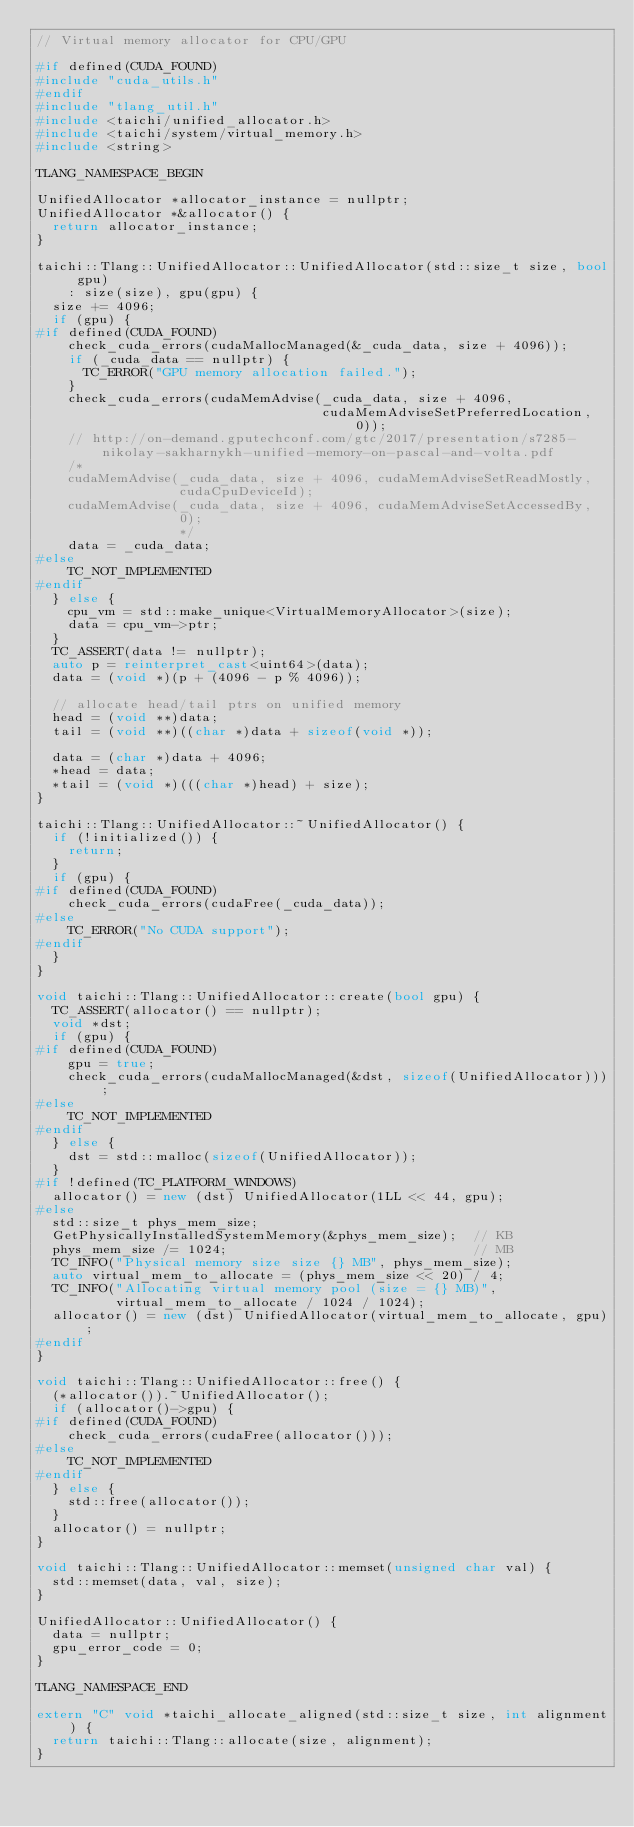Convert code to text. <code><loc_0><loc_0><loc_500><loc_500><_C++_>// Virtual memory allocator for CPU/GPU

#if defined(CUDA_FOUND)
#include "cuda_utils.h"
#endif
#include "tlang_util.h"
#include <taichi/unified_allocator.h>
#include <taichi/system/virtual_memory.h>
#include <string>

TLANG_NAMESPACE_BEGIN

UnifiedAllocator *allocator_instance = nullptr;
UnifiedAllocator *&allocator() {
  return allocator_instance;
}

taichi::Tlang::UnifiedAllocator::UnifiedAllocator(std::size_t size, bool gpu)
    : size(size), gpu(gpu) {
  size += 4096;
  if (gpu) {
#if defined(CUDA_FOUND)
    check_cuda_errors(cudaMallocManaged(&_cuda_data, size + 4096));
    if (_cuda_data == nullptr) {
      TC_ERROR("GPU memory allocation failed.");
    }
    check_cuda_errors(cudaMemAdvise(_cuda_data, size + 4096,
                                    cudaMemAdviseSetPreferredLocation, 0));
    // http://on-demand.gputechconf.com/gtc/2017/presentation/s7285-nikolay-sakharnykh-unified-memory-on-pascal-and-volta.pdf
    /*
    cudaMemAdvise(_cuda_data, size + 4096, cudaMemAdviseSetReadMostly,
                  cudaCpuDeviceId);
    cudaMemAdvise(_cuda_data, size + 4096, cudaMemAdviseSetAccessedBy,
                  0);
                  */
    data = _cuda_data;
#else
    TC_NOT_IMPLEMENTED
#endif
  } else {
    cpu_vm = std::make_unique<VirtualMemoryAllocator>(size);
    data = cpu_vm->ptr;
  }
  TC_ASSERT(data != nullptr);
  auto p = reinterpret_cast<uint64>(data);
  data = (void *)(p + (4096 - p % 4096));

  // allocate head/tail ptrs on unified memory
  head = (void **)data;
  tail = (void **)((char *)data + sizeof(void *));

  data = (char *)data + 4096;
  *head = data;
  *tail = (void *)(((char *)head) + size);
}

taichi::Tlang::UnifiedAllocator::~UnifiedAllocator() {
  if (!initialized()) {
    return;
  }
  if (gpu) {
#if defined(CUDA_FOUND)
    check_cuda_errors(cudaFree(_cuda_data));
#else
    TC_ERROR("No CUDA support");
#endif
  }
}

void taichi::Tlang::UnifiedAllocator::create(bool gpu) {
  TC_ASSERT(allocator() == nullptr);
  void *dst;
  if (gpu) {
#if defined(CUDA_FOUND)
    gpu = true;
    check_cuda_errors(cudaMallocManaged(&dst, sizeof(UnifiedAllocator)));
#else
    TC_NOT_IMPLEMENTED
#endif
  } else {
    dst = std::malloc(sizeof(UnifiedAllocator));
  }
#if !defined(TC_PLATFORM_WINDOWS)
  allocator() = new (dst) UnifiedAllocator(1LL << 44, gpu);
#else
  std::size_t phys_mem_size;
  GetPhysicallyInstalledSystemMemory(&phys_mem_size);  // KB
  phys_mem_size /= 1024;                               // MB
  TC_INFO("Physical memory size size {} MB", phys_mem_size);
  auto virtual_mem_to_allocate = (phys_mem_size << 20) / 4;
  TC_INFO("Allocating virtual memory pool (size = {} MB)",
          virtual_mem_to_allocate / 1024 / 1024);
  allocator() = new (dst) UnifiedAllocator(virtual_mem_to_allocate, gpu);
#endif
}

void taichi::Tlang::UnifiedAllocator::free() {
  (*allocator()).~UnifiedAllocator();
  if (allocator()->gpu) {
#if defined(CUDA_FOUND)
    check_cuda_errors(cudaFree(allocator()));
#else
    TC_NOT_IMPLEMENTED
#endif
  } else {
    std::free(allocator());
  }
  allocator() = nullptr;
}

void taichi::Tlang::UnifiedAllocator::memset(unsigned char val) {
  std::memset(data, val, size);
}

UnifiedAllocator::UnifiedAllocator() {
  data = nullptr;
  gpu_error_code = 0;
}

TLANG_NAMESPACE_END

extern "C" void *taichi_allocate_aligned(std::size_t size, int alignment) {
  return taichi::Tlang::allocate(size, alignment);
}
</code> 